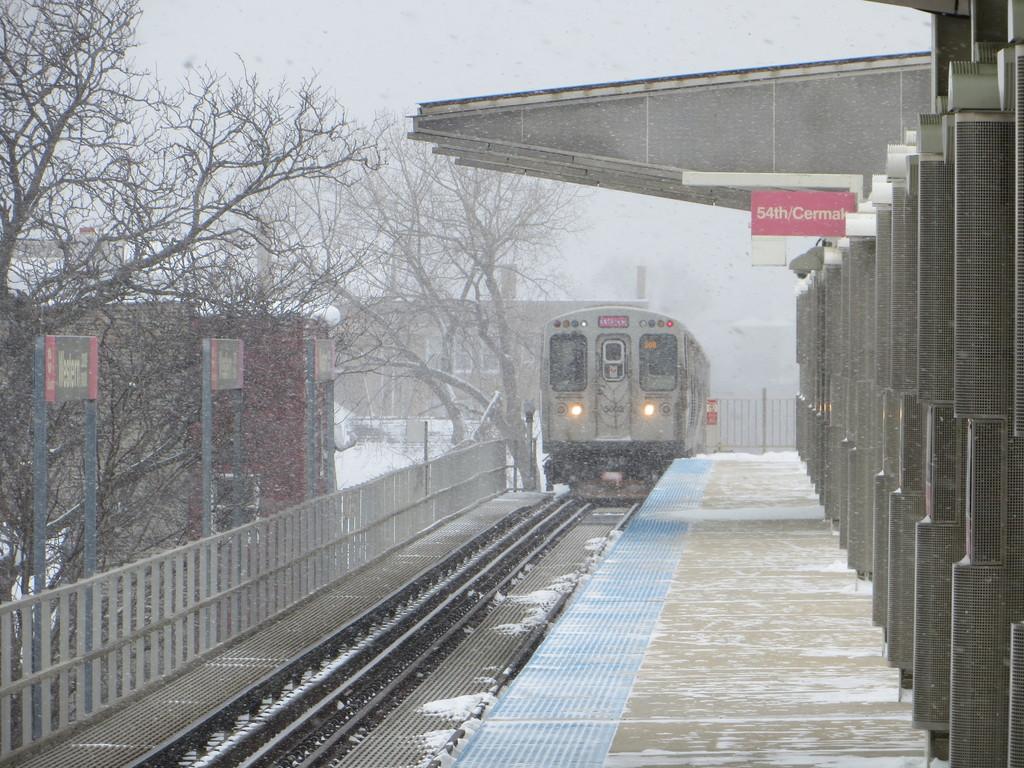Which station is this?
Offer a terse response. 54th. 